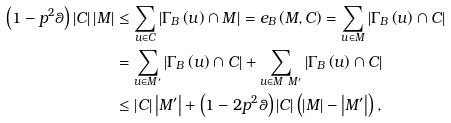<formula> <loc_0><loc_0><loc_500><loc_500>\left ( 1 - p ^ { 2 } \theta \right ) \left | C \right | \left | M \right | & \leq \sum _ { u \in C } \left | \Gamma _ { B } \left ( u \right ) \cap M \right | = e _ { B } \left ( M , C \right ) = \sum _ { u \in M } \left | \Gamma _ { B } \left ( u \right ) \cap C \right | \\ & = \sum _ { u \in M ^ { \prime } } \left | \Gamma _ { B } \left ( u \right ) \cap C \right | + \sum _ { u \in M \ M ^ { \prime } } \left | \Gamma _ { B } \left ( u \right ) \cap C \right | \\ & \leq \left | C \right | \left | M ^ { \prime } \right | + \left ( 1 - 2 p ^ { 2 } \theta \right ) \left | C \right | \left ( \left | M \right | - \left | M ^ { \prime } \right | \right ) ,</formula> 